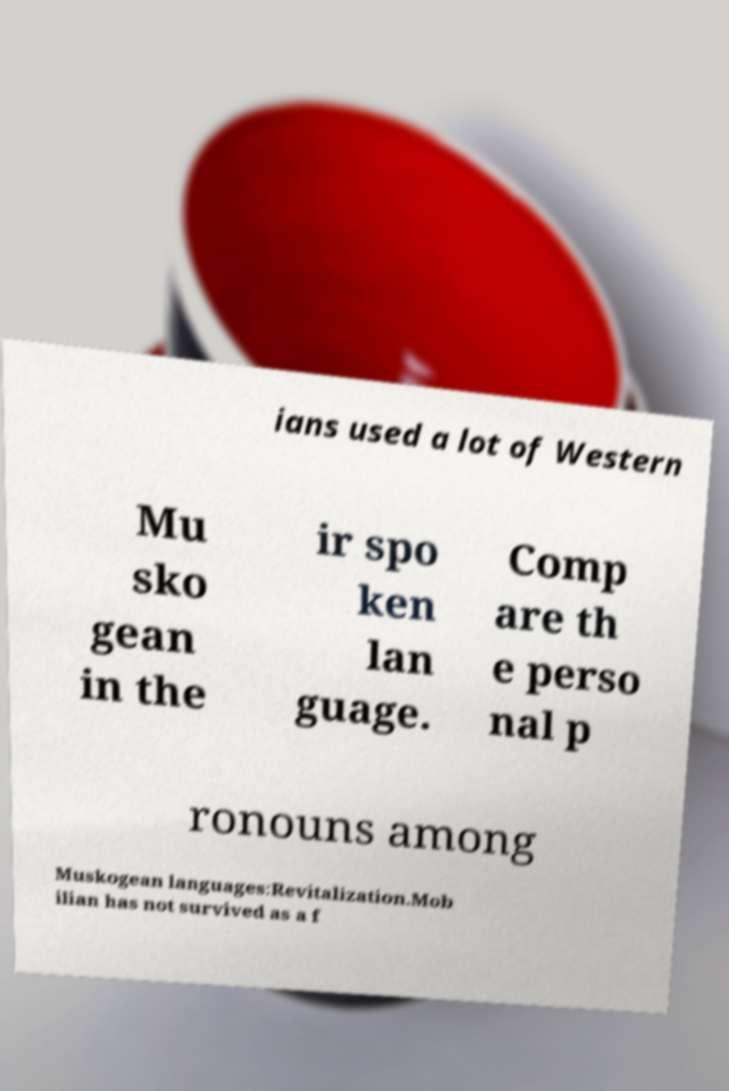Please identify and transcribe the text found in this image. ians used a lot of Western Mu sko gean in the ir spo ken lan guage. Comp are th e perso nal p ronouns among Muskogean languages:Revitalization.Mob ilian has not survived as a f 